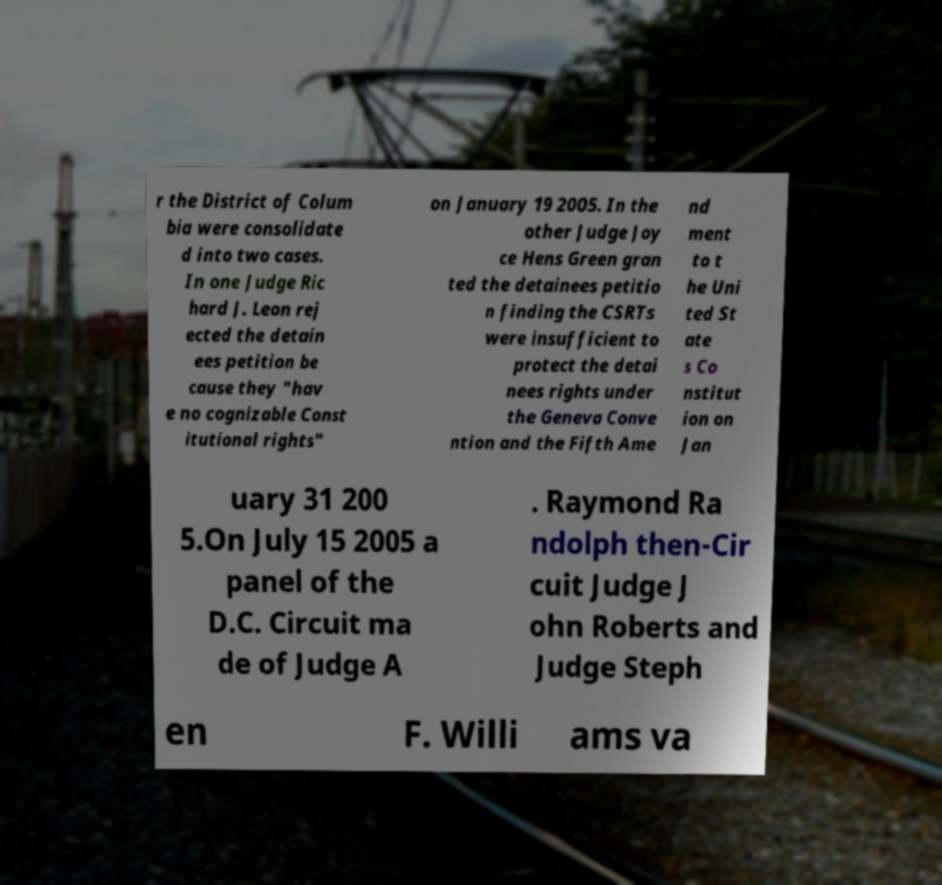Can you read and provide the text displayed in the image?This photo seems to have some interesting text. Can you extract and type it out for me? r the District of Colum bia were consolidate d into two cases. In one Judge Ric hard J. Leon rej ected the detain ees petition be cause they "hav e no cognizable Const itutional rights" on January 19 2005. In the other Judge Joy ce Hens Green gran ted the detainees petitio n finding the CSRTs were insufficient to protect the detai nees rights under the Geneva Conve ntion and the Fifth Ame nd ment to t he Uni ted St ate s Co nstitut ion on Jan uary 31 200 5.On July 15 2005 a panel of the D.C. Circuit ma de of Judge A . Raymond Ra ndolph then-Cir cuit Judge J ohn Roberts and Judge Steph en F. Willi ams va 